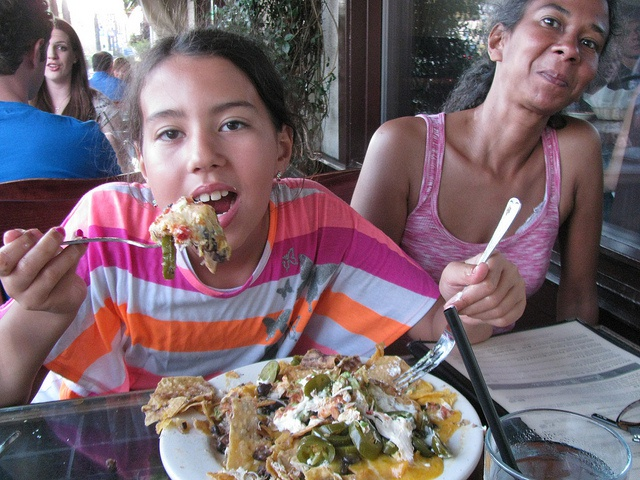Describe the objects in this image and their specific colors. I can see people in black, gray, brown, darkgray, and lavender tones, people in black, brown, gray, and maroon tones, dining table in black, darkgray, and gray tones, people in black, blue, and navy tones, and potted plant in black, gray, and darkgray tones in this image. 